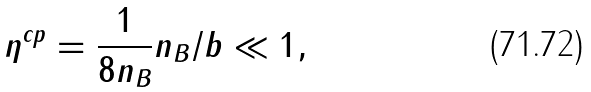Convert formula to latex. <formula><loc_0><loc_0><loc_500><loc_500>\eta ^ { c p } = \frac { 1 } { 8 n _ { B } } n _ { B } / b \ll 1 ,</formula> 